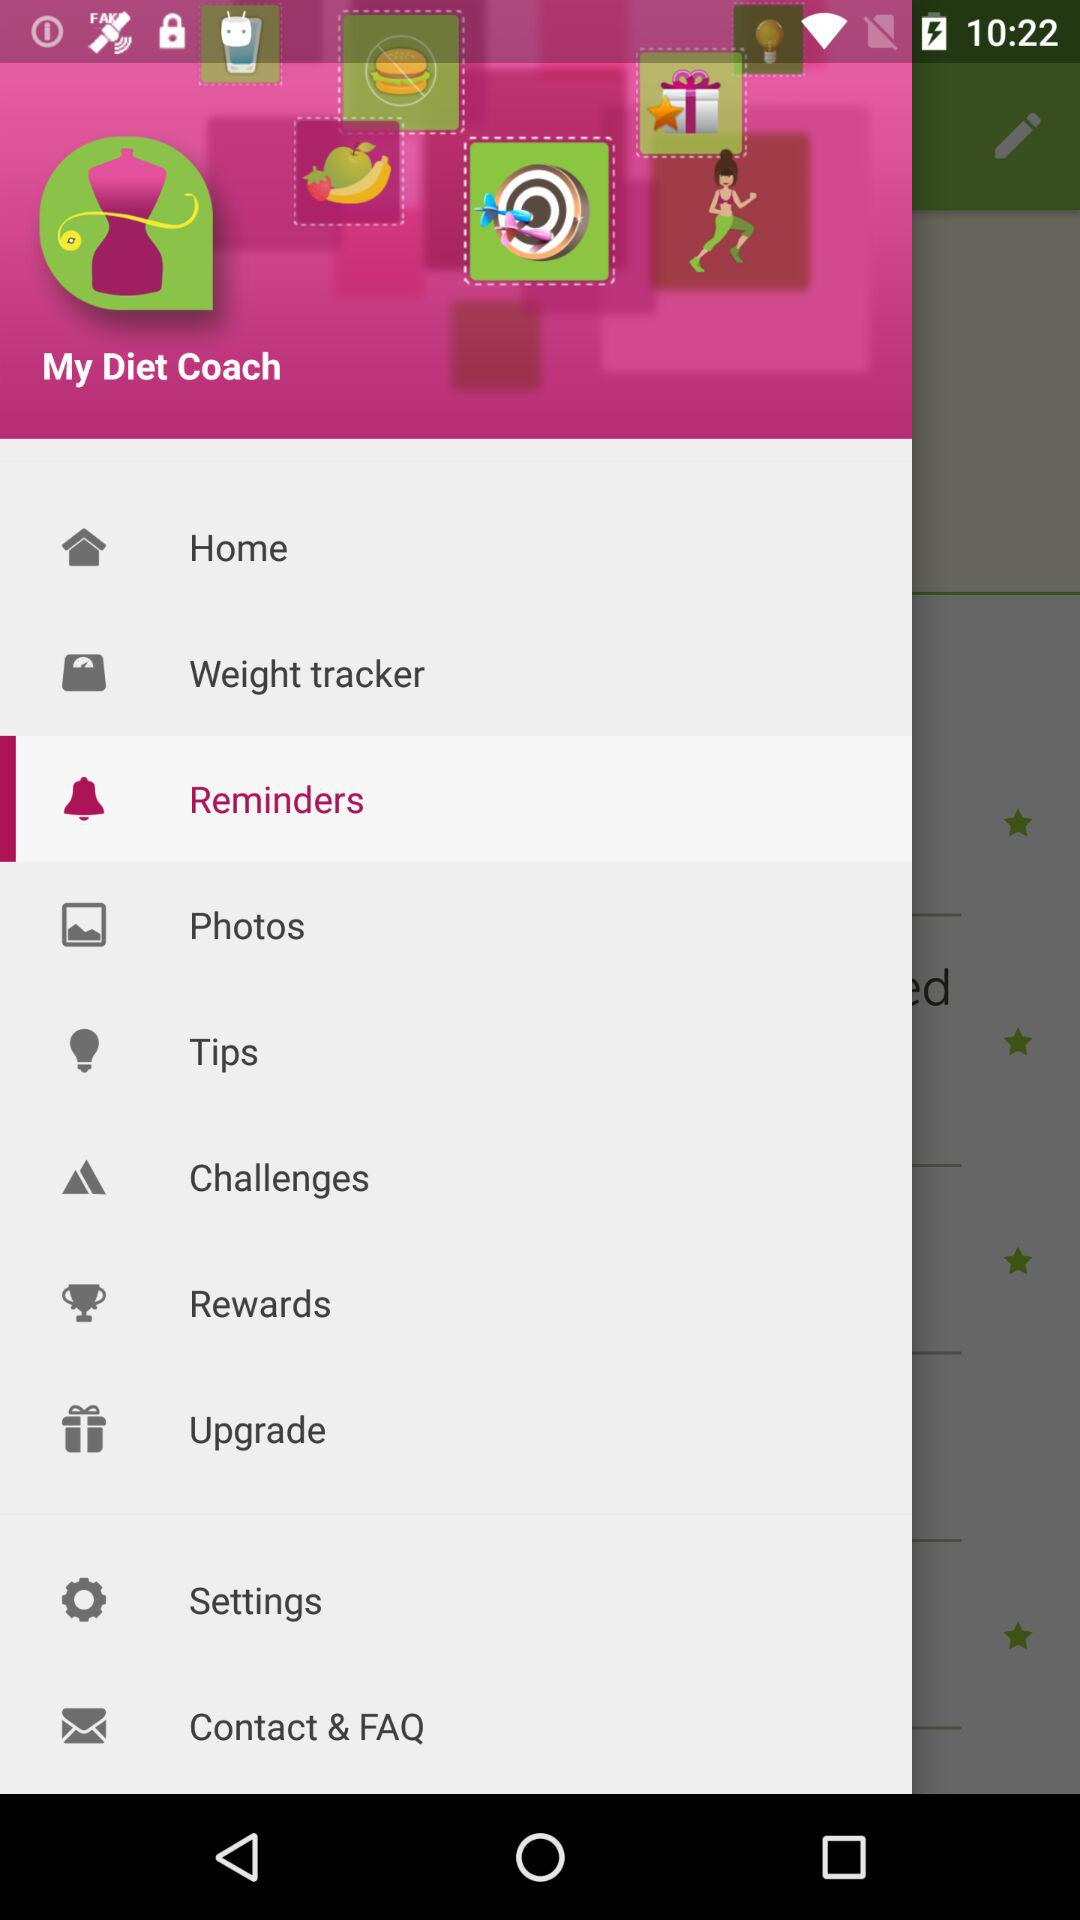What is the name of the application? The name of the application is "My Diet Coach". 